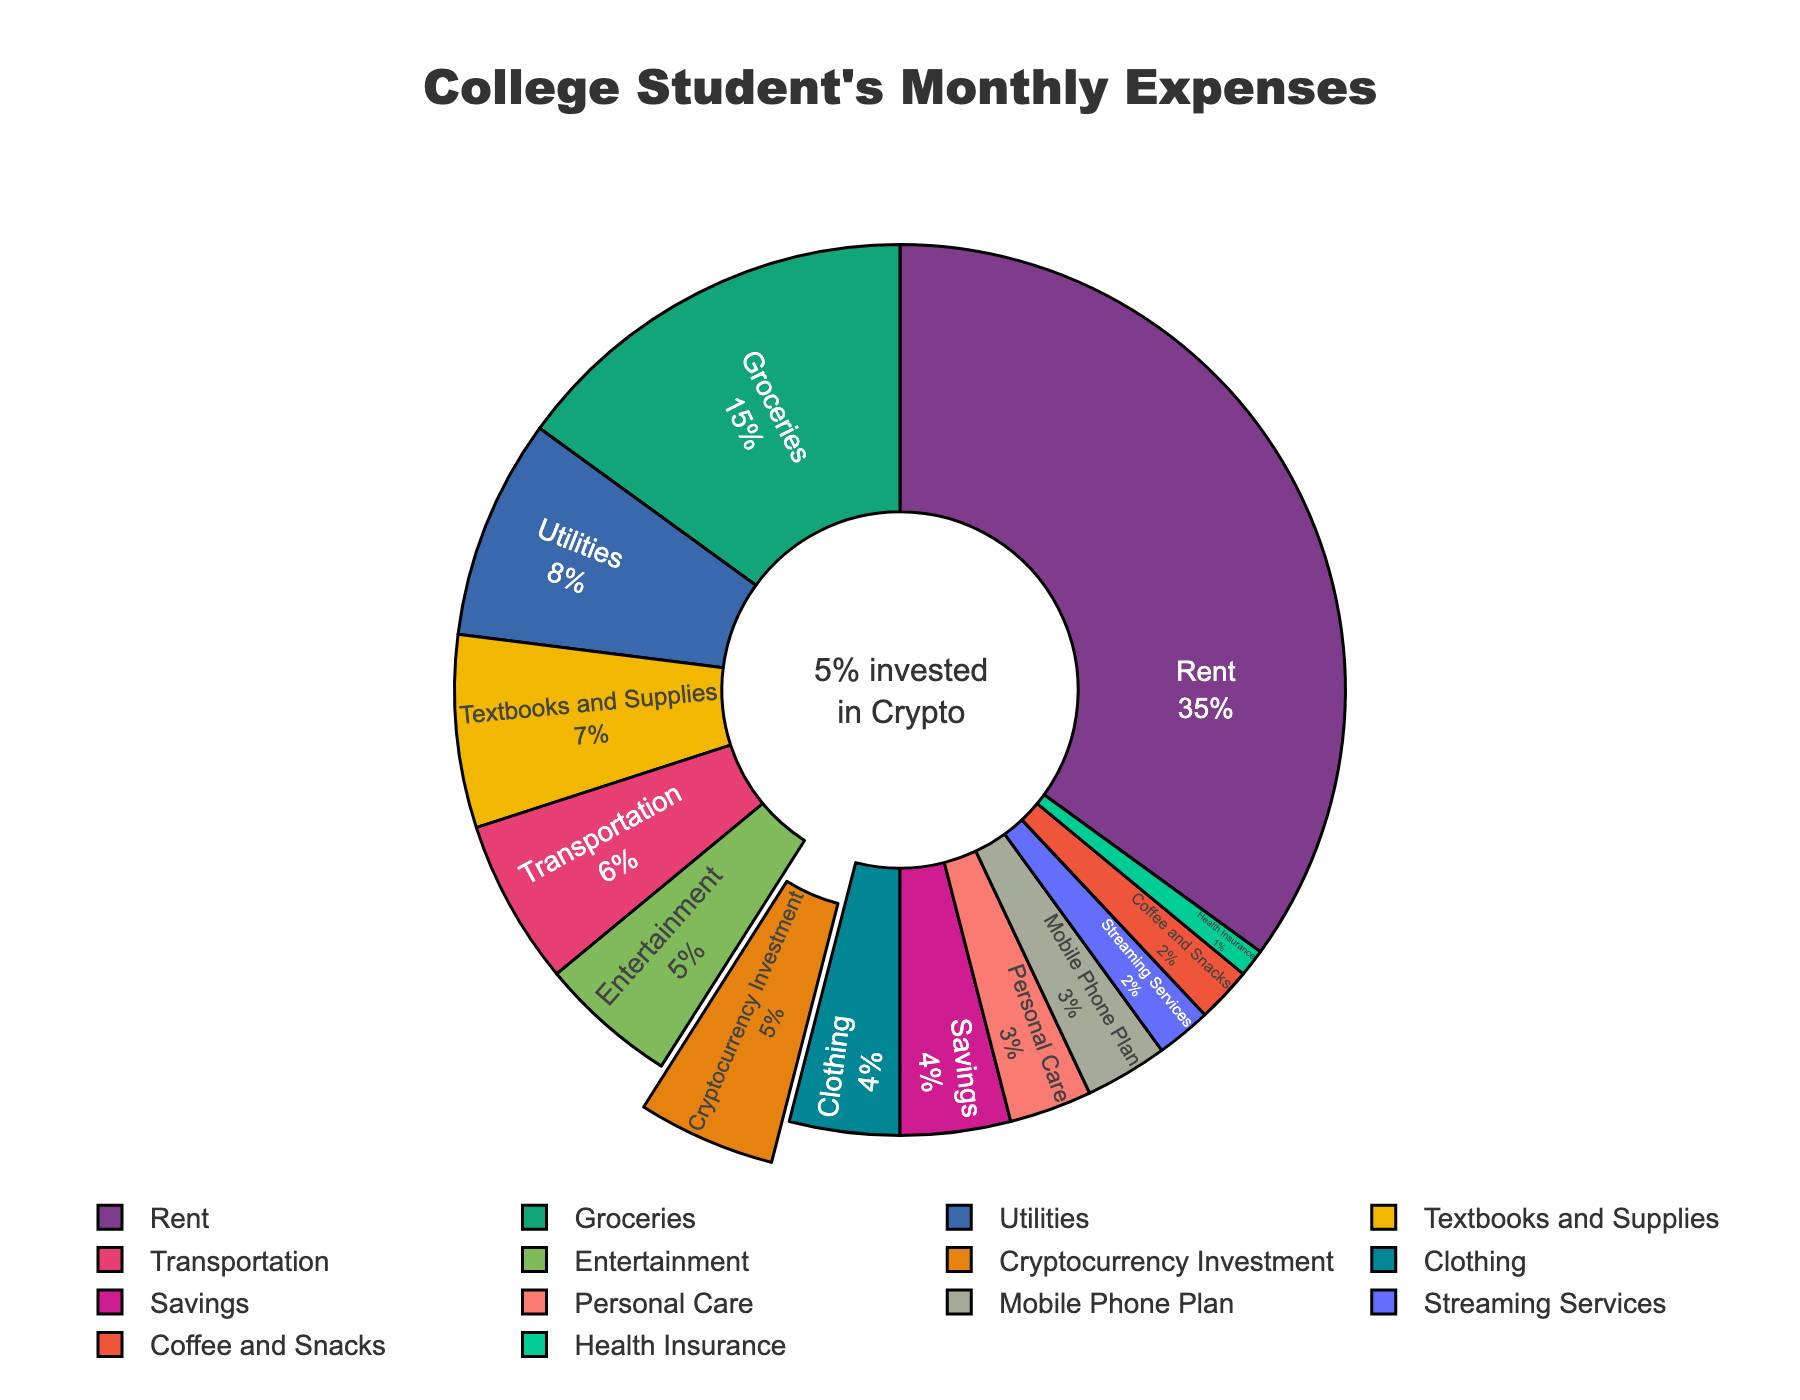What percentage of college students' expenses go toward rent and groceries combined? Rent is 35% and groceries are 15%. Adding these percentages together gives 35 + 15 = 50%.
Answer: 50% Which category has the lowest percentage of expenses, and how much is it? The category with the lowest percentage of expenses is Health Insurance at 1%.
Answer: Health Insurance, 1% How does the percentage spent on cryptocurrency investment compare to that spent on entertainment? Cryptocurrency Investment is 5% while Entertainment is 5%. Comparing these, they are equal.
Answer: They are equal What is the sum of the expenses categories that are below 5%? Categories below 5% are Utilities (8%), Textbooks and Supplies (7%), Transportation (6%), Entertainment (5%), Clothing (4%), Savings (4%), Mobile Phone Plan (3%), Personal Care (3%), Streaming Services (2%), Coffee and Snacks (2%), Health Insurance (1%). Summing these gives 8 + 7 + 6 + 5 + 4 + 4 + 3 + 3 + 2 + 2 + 1 = 45%.
Answer: 45% What is the difference in percentage between the highest and lowest spending categories? The highest spending category is Rent at 35%. The lowest is Health Insurance at 1%. The difference is 35 - 1 = 34%.
Answer: 34% Which categories are painted in the boldest colors for easier visualization? Categories with bold colors are Rent, Groceries, Utilities, Textbooks and Supplies, Transportation, Entertainment, Cryptocurrency Investment. These colors stand out more.
Answer: Rent, Groceries, Utilities, Textbooks and Supplies, Transportation, Entertainment, Cryptocurrency Investment How many categories have percentages exactly at or above 5%? Categories with percentages of 5% or above are Rent (35%), Groceries (15%), Utilities (8%), Textbooks and Supplies (7%), Transportation (6%), Entertainment (5%), Cryptocurrency Investment (5%). There are 7 categories.
Answer: 7 What percentage of expenses do categories labeled as 'personal needs' (Clothing, Personal Care) account for? Clothing is 4% and Personal Care is 3%. Adding these gives 4 + 3 = 7%.
Answer: 7% By how much do the expenses on transportation and groceries differ? Groceries are 15% and transportation is 6%. The difference is 15 - 6 = 9%.
Answer: 9% Which expense category stands out visually due to being 'pulled out' in the pie chart, and why might it be highlighted? The pulled-out category is Cryptocurrency Investment at 5%. It might be highlighted to draw attention to the emerging trend of digital investments among college students.
Answer: Cryptocurrency Investment, to highlight the trend 